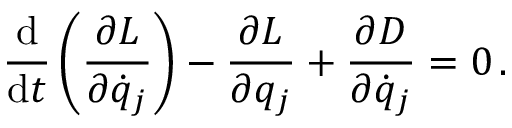<formula> <loc_0><loc_0><loc_500><loc_500>{ \frac { d } { d t } } \left ( { \frac { \partial L } { \partial { \dot { q } } _ { j } } } \right ) - { \frac { \partial L } { \partial q _ { j } } } + { \frac { \partial D } { \partial { \dot { q } } _ { j } } } = 0 \, .</formula> 